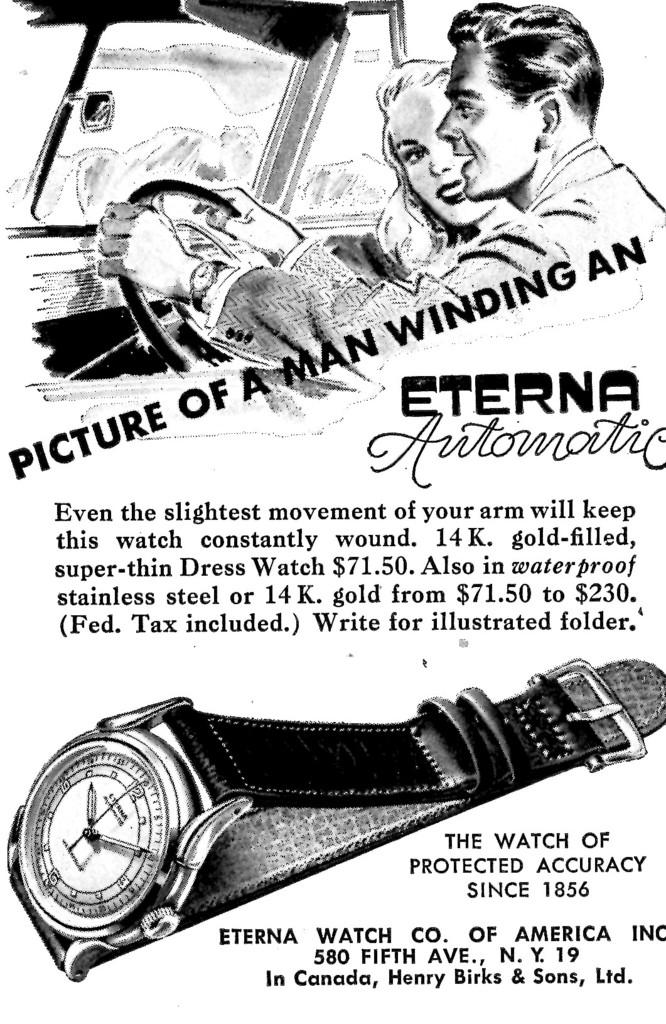What's the brand name of this watch?
Your response must be concise. Eterna. How much does the watch go for?
Make the answer very short. 71.50. 